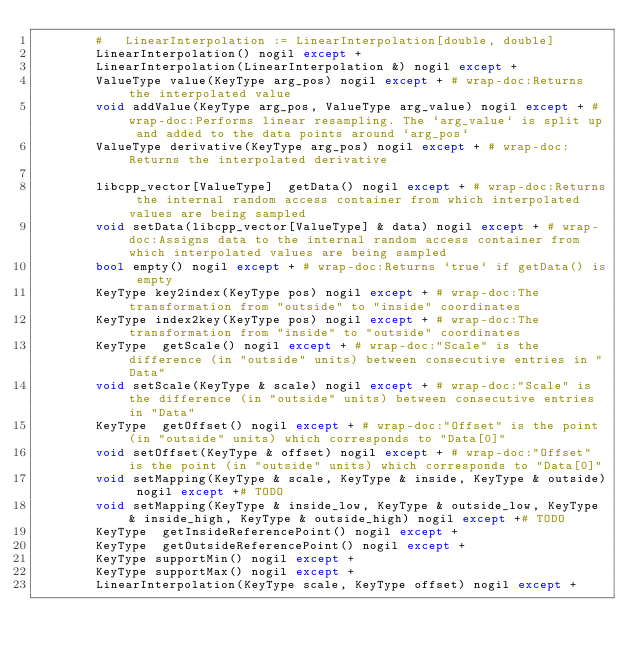Convert code to text. <code><loc_0><loc_0><loc_500><loc_500><_Cython_>        #   LinearInterpolation := LinearInterpolation[double, double]
        LinearInterpolation() nogil except +
        LinearInterpolation(LinearInterpolation &) nogil except +
        ValueType value(KeyType arg_pos) nogil except + # wrap-doc:Returns the interpolated value
        void addValue(KeyType arg_pos, ValueType arg_value) nogil except + # wrap-doc:Performs linear resampling. The `arg_value` is split up and added to the data points around `arg_pos`
        ValueType derivative(KeyType arg_pos) nogil except + # wrap-doc:Returns the interpolated derivative

        libcpp_vector[ValueType]  getData() nogil except + # wrap-doc:Returns the internal random access container from which interpolated values are being sampled
        void setData(libcpp_vector[ValueType] & data) nogil except + # wrap-doc:Assigns data to the internal random access container from which interpolated values are being sampled
        bool empty() nogil except + # wrap-doc:Returns `true` if getData() is empty
        KeyType key2index(KeyType pos) nogil except + # wrap-doc:The transformation from "outside" to "inside" coordinates
        KeyType index2key(KeyType pos) nogil except + # wrap-doc:The transformation from "inside" to "outside" coordinates
        KeyType  getScale() nogil except + # wrap-doc:"Scale" is the difference (in "outside" units) between consecutive entries in "Data"
        void setScale(KeyType & scale) nogil except + # wrap-doc:"Scale" is the difference (in "outside" units) between consecutive entries in "Data"
        KeyType  getOffset() nogil except + # wrap-doc:"Offset" is the point (in "outside" units) which corresponds to "Data[0]"
        void setOffset(KeyType & offset) nogil except + # wrap-doc:"Offset" is the point (in "outside" units) which corresponds to "Data[0]"
        void setMapping(KeyType & scale, KeyType & inside, KeyType & outside) nogil except +# TODO
        void setMapping(KeyType & inside_low, KeyType & outside_low, KeyType & inside_high, KeyType & outside_high) nogil except +# TODO
        KeyType  getInsideReferencePoint() nogil except + 
        KeyType  getOutsideReferencePoint() nogil except +
        KeyType supportMin() nogil except +
        KeyType supportMax() nogil except +
        LinearInterpolation(KeyType scale, KeyType offset) nogil except +
</code> 